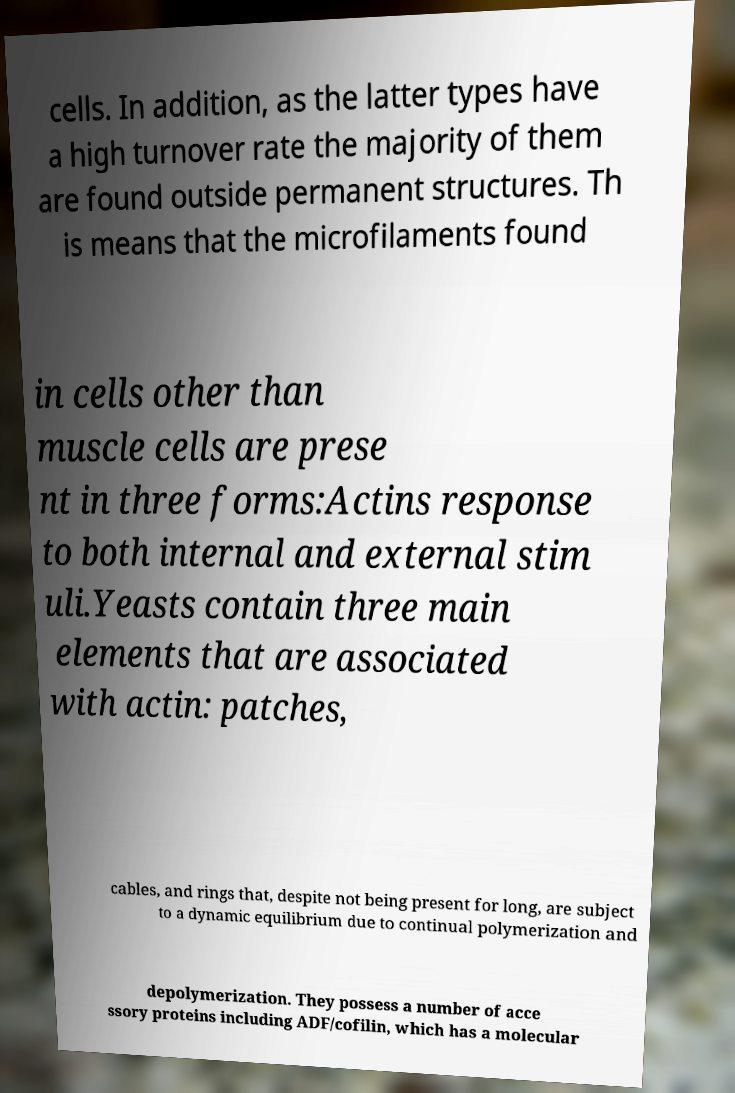For documentation purposes, I need the text within this image transcribed. Could you provide that? cells. In addition, as the latter types have a high turnover rate the majority of them are found outside permanent structures. Th is means that the microfilaments found in cells other than muscle cells are prese nt in three forms:Actins response to both internal and external stim uli.Yeasts contain three main elements that are associated with actin: patches, cables, and rings that, despite not being present for long, are subject to a dynamic equilibrium due to continual polymerization and depolymerization. They possess a number of acce ssory proteins including ADF/cofilin, which has a molecular 